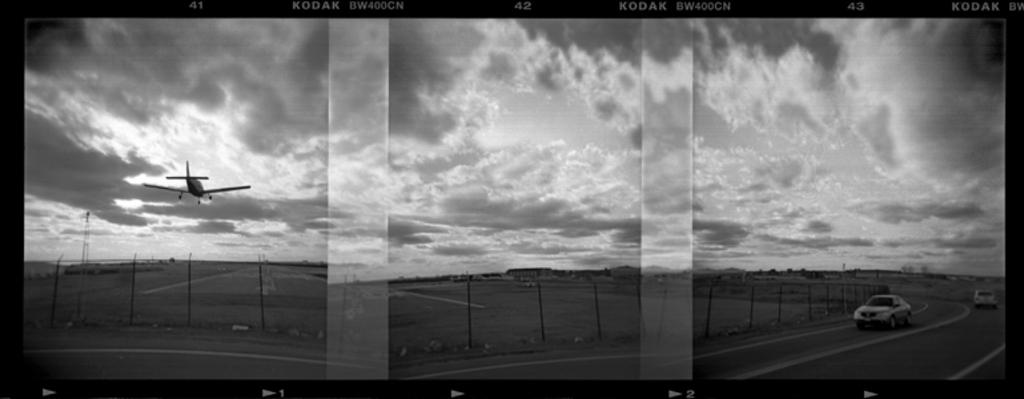Which film company is thisfrom?
Provide a short and direct response. Kodak. What is the 1st number in the top row?
Offer a terse response. 41. 